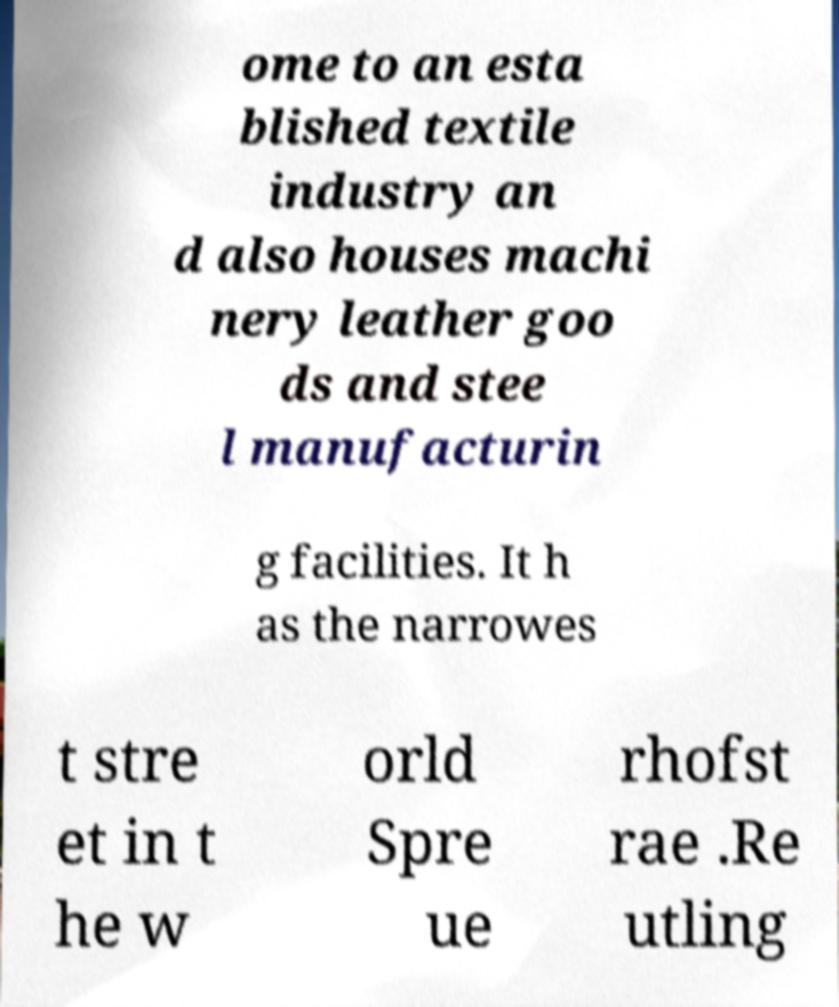Please identify and transcribe the text found in this image. ome to an esta blished textile industry an d also houses machi nery leather goo ds and stee l manufacturin g facilities. It h as the narrowes t stre et in t he w orld Spre ue rhofst rae .Re utling 